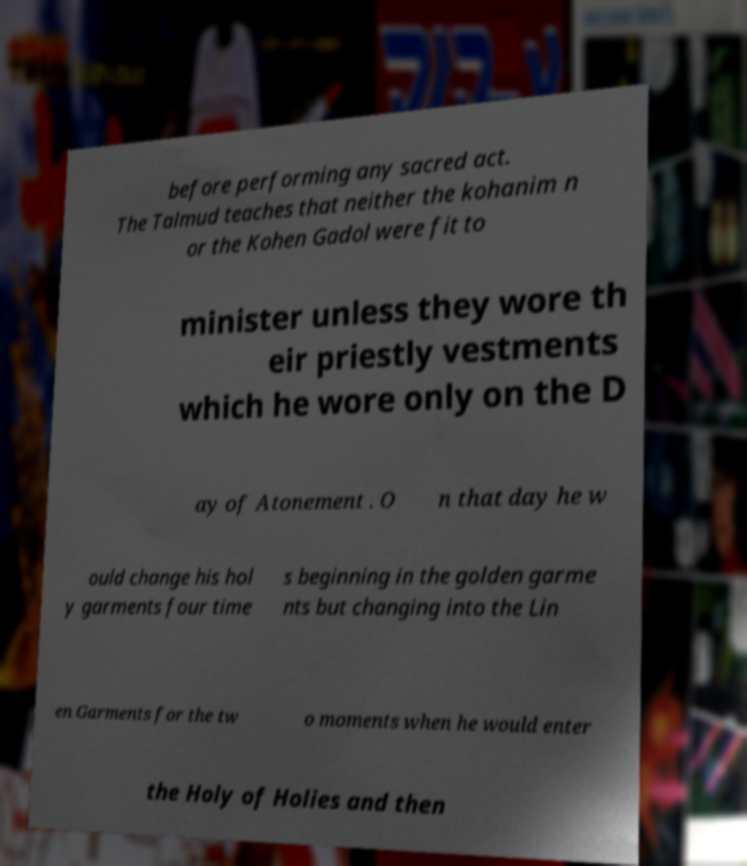What messages or text are displayed in this image? I need them in a readable, typed format. before performing any sacred act. The Talmud teaches that neither the kohanim n or the Kohen Gadol were fit to minister unless they wore th eir priestly vestments which he wore only on the D ay of Atonement . O n that day he w ould change his hol y garments four time s beginning in the golden garme nts but changing into the Lin en Garments for the tw o moments when he would enter the Holy of Holies and then 